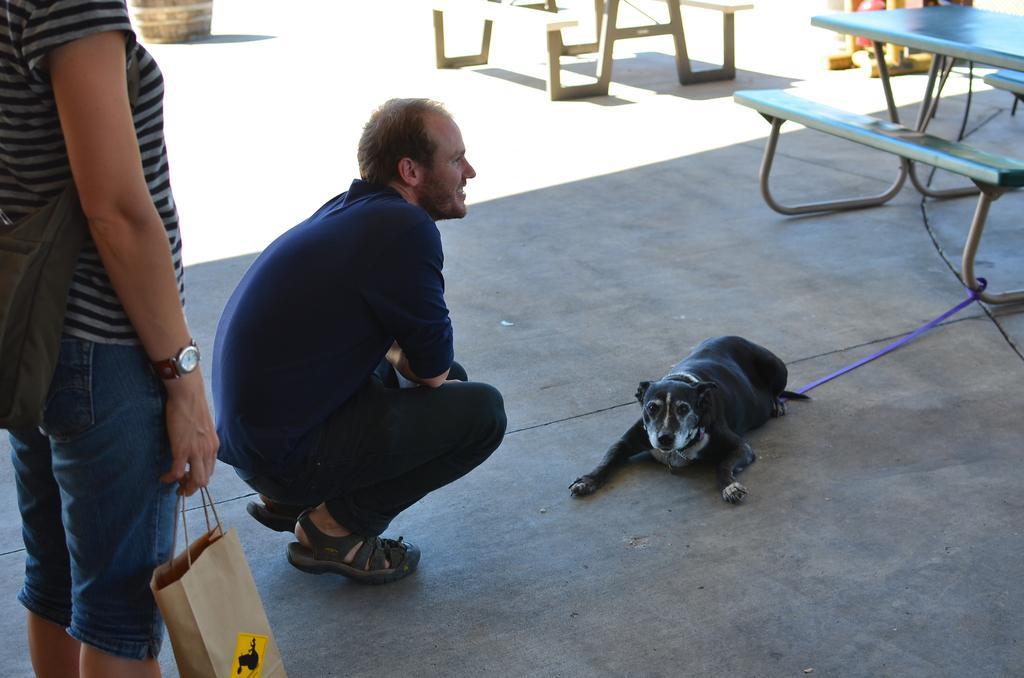In one or two sentences, can you explain what this image depicts? Man in blue t-shirt is sitting in squat position and he is smiling. In front of him, we see a dog lying on the floor. On left corner, we see women wearing backpack and she is carrying bag in her hand. On the right top of the picture, we see a table with bench. 